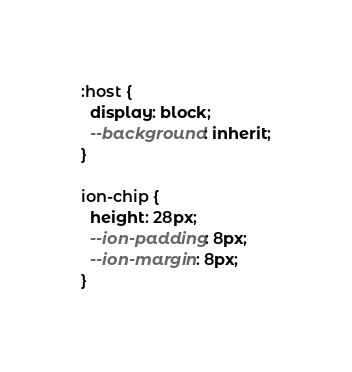Convert code to text. <code><loc_0><loc_0><loc_500><loc_500><_CSS_>:host {
  display: block;
  --background: inherit;
}

ion-chip {
  height: 28px;
  --ion-padding: 8px;
  --ion-margin: 8px;
}
</code> 